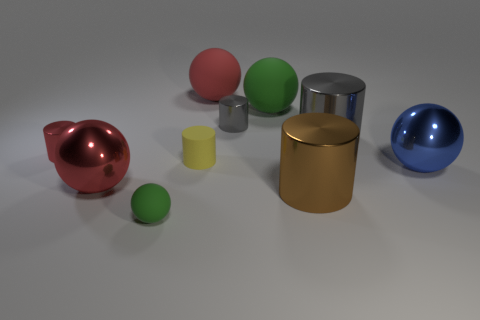Subtract all large red matte spheres. How many spheres are left? 4 Subtract all blue balls. How many gray cylinders are left? 2 Subtract 1 balls. How many balls are left? 4 Subtract all blue spheres. How many spheres are left? 4 Subtract all purple cylinders. Subtract all blue spheres. How many cylinders are left? 5 Add 3 small red cylinders. How many small red cylinders exist? 4 Subtract 0 blue cylinders. How many objects are left? 10 Subtract all gray objects. Subtract all red spheres. How many objects are left? 6 Add 5 large red shiny balls. How many large red shiny balls are left? 6 